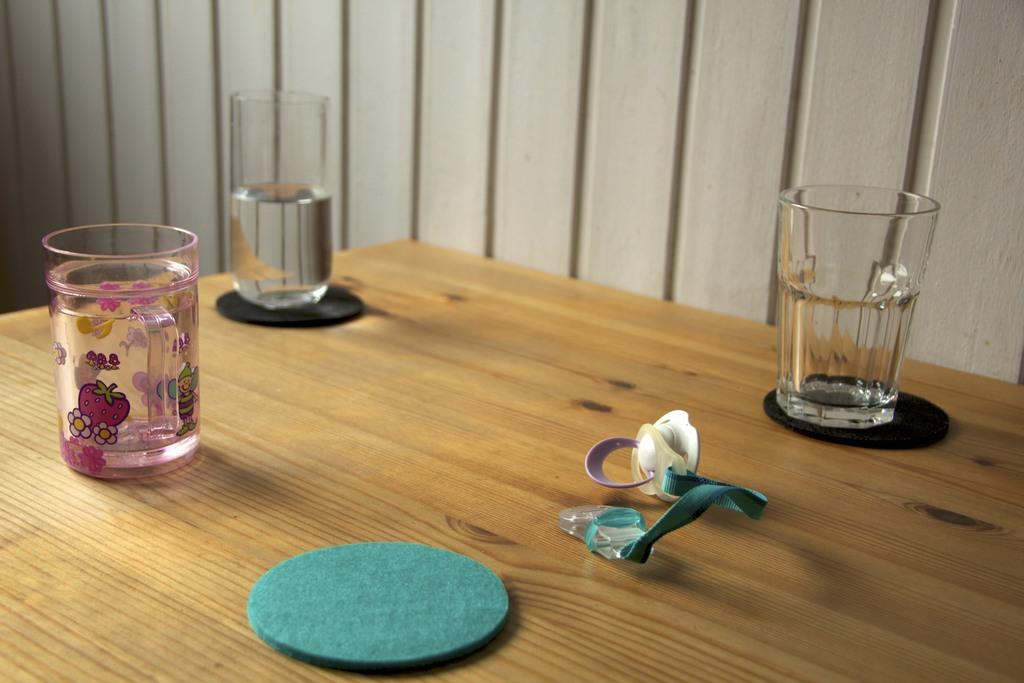What piece of furniture is present in the image? There is a table in the image. What objects are on the table in the image? There are three glasses on the table. What nation is represented by the flag on the table in the image? There is no flag present on the table in the image. What type of toothpaste is visible in the image? There is no toothpaste present in the image. Where is the cave located in the image? There is no cave present in the image. 